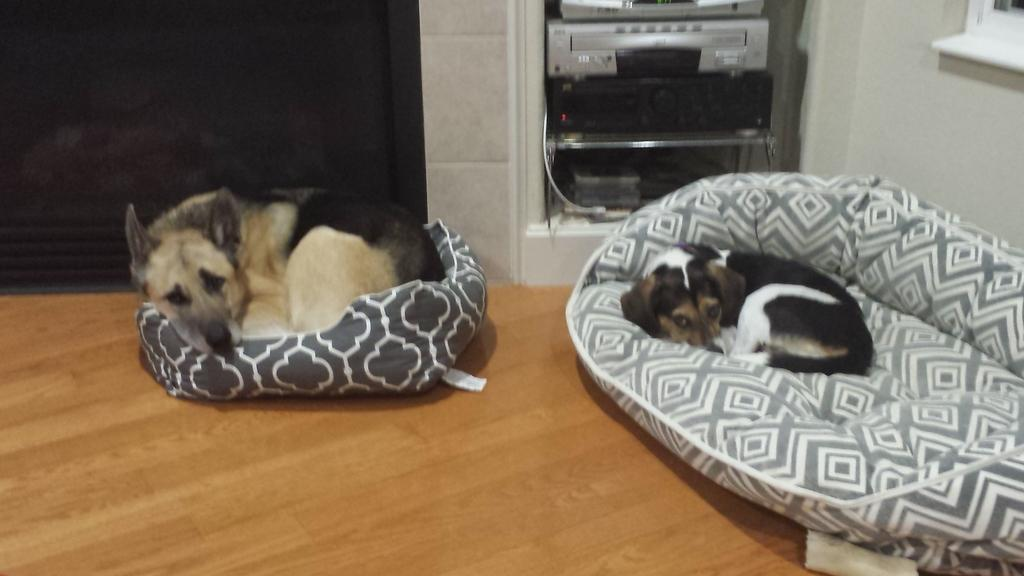How many dogs are present in the image? There are two dogs in the image. What are the dogs doing in the image? The dogs are laying on pet beds. What can be seen in the background of the image? There is a music player and a wall in the background of the image. What type of grass is growing on the arch in the image? There is no grass or arch present in the image. 